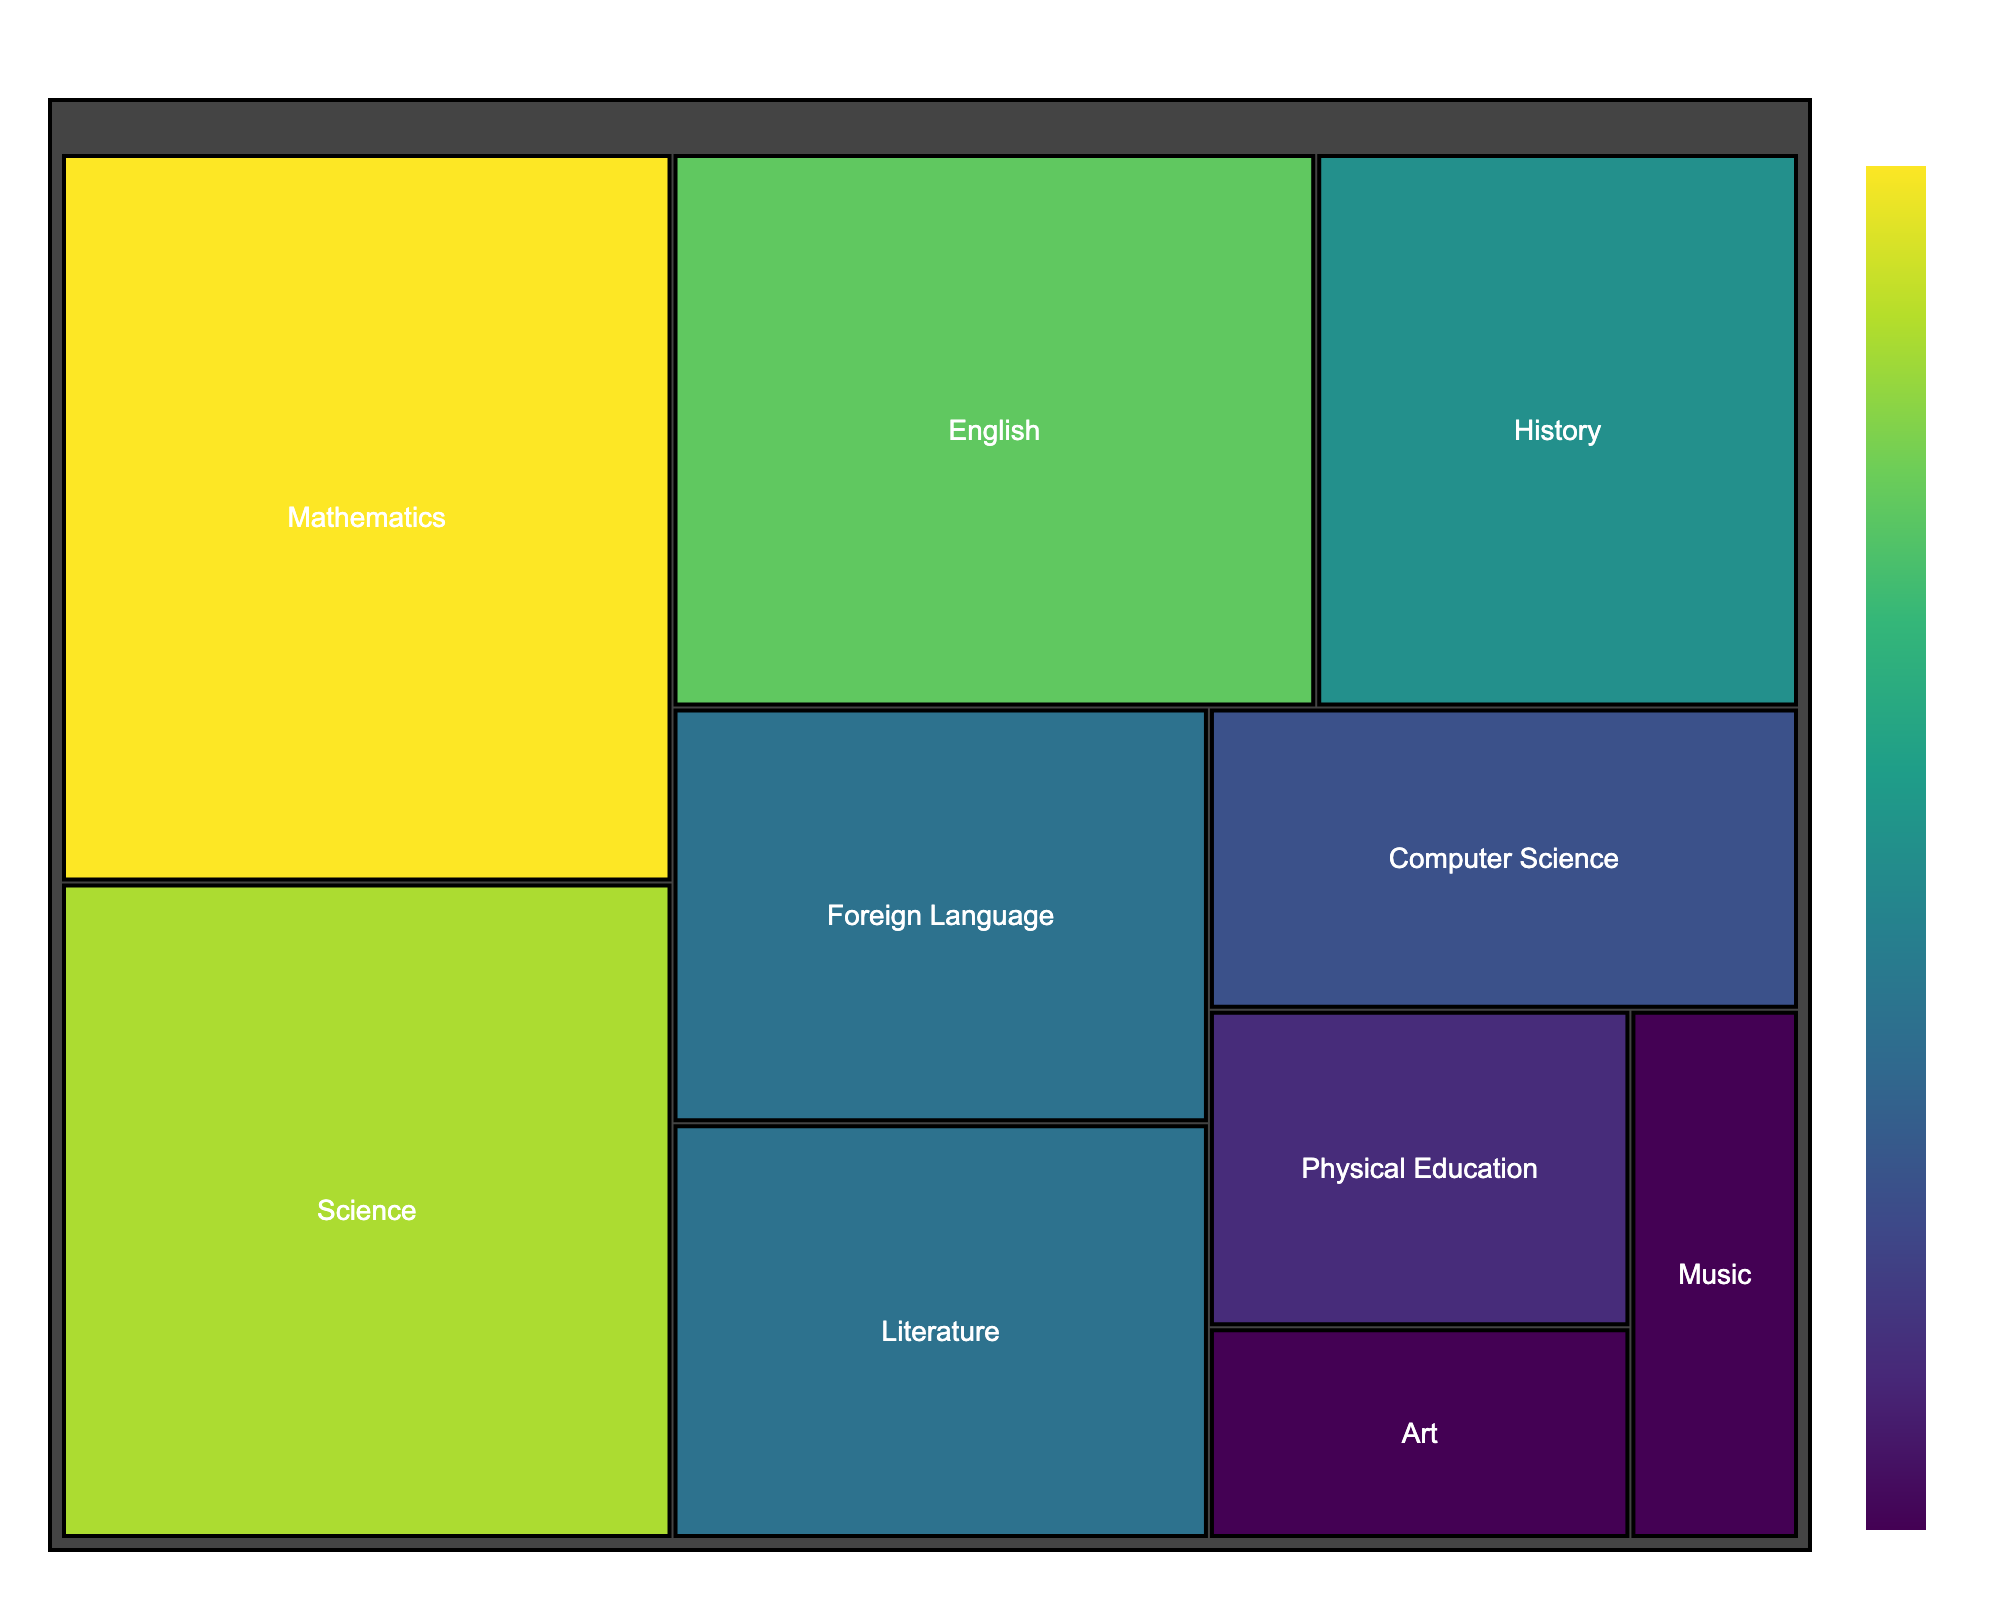what is the main title of the plot? The title is usually found at the top of the plot, centrally aligned and displayed in a larger font size for ease of visibility.
Answer: Distribution of High School Students' Study Time Across Subjects which subject has the highest study hours? By looking at the size of the blocks in the treemap, the largest block represents the subject with the highest study hours.
Answer: Mathematics what is the smallest block in the treemap? The smallest block corresponds to the subject with the lowest study hours.
Answer: Art how many subjects have a study time of 5 hours or more? First, identify the blocks that indicate 5 hours or more and then count them. There are five subjects: Mathematics, English, Science, History, and Literature.
Answer: Five how does the study time of Science compare to that of English? Locate the blocks for Science and English. Both the size and the numerical value can be used to compare. Science has 9 hours, while English has 8 hours.
Answer: Science has more study hours what is the total study time for all subjects combined? Sum up the study hours of all subjects: 10+8+9+6+5+3+2+4+2+5 = 54
Answer: 54 hours what is the average study time per subject? First, calculate the total study hours (54), then divide by the number of subjects (10). So, 54/10 = 5.4
Answer: 5.4 hours which subjects have equal study hours, and what are the hours? Identify blocks with identical sizes and numerical values representing their study hours. Both Art and Music have 2 study hours each.
Answer: Art and Music, 2 hours if we combine the study hours of Physical Education and Computer Science, which subject would they surpass in study time? Add the study hours of Physical Education and Computer Science (3+4=7). Compare this with other subjects. They surpass History (6 hours).
Answer: History what is the color range used in the treemap? The color range represents the study hours and varies from light to dark shades, with the dark shade indicating higher study hours in the 'Viridis' color scale. Light to dark shades in the 'Viridis' color scale.
Answer: Light to dark shades in the 'Viridis' color scale 